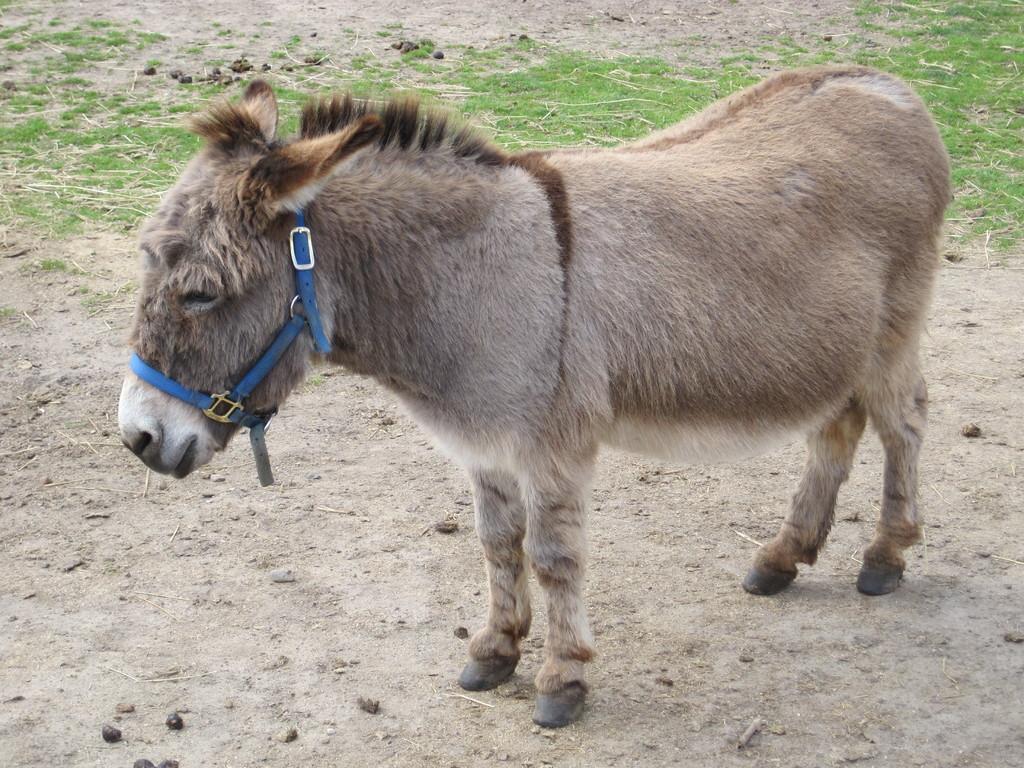Please provide a concise description of this image. In the center of the image we can see a donkey. And we can see a belt is attached on the face of a donkey. In the background, we can see the grass and soil. 